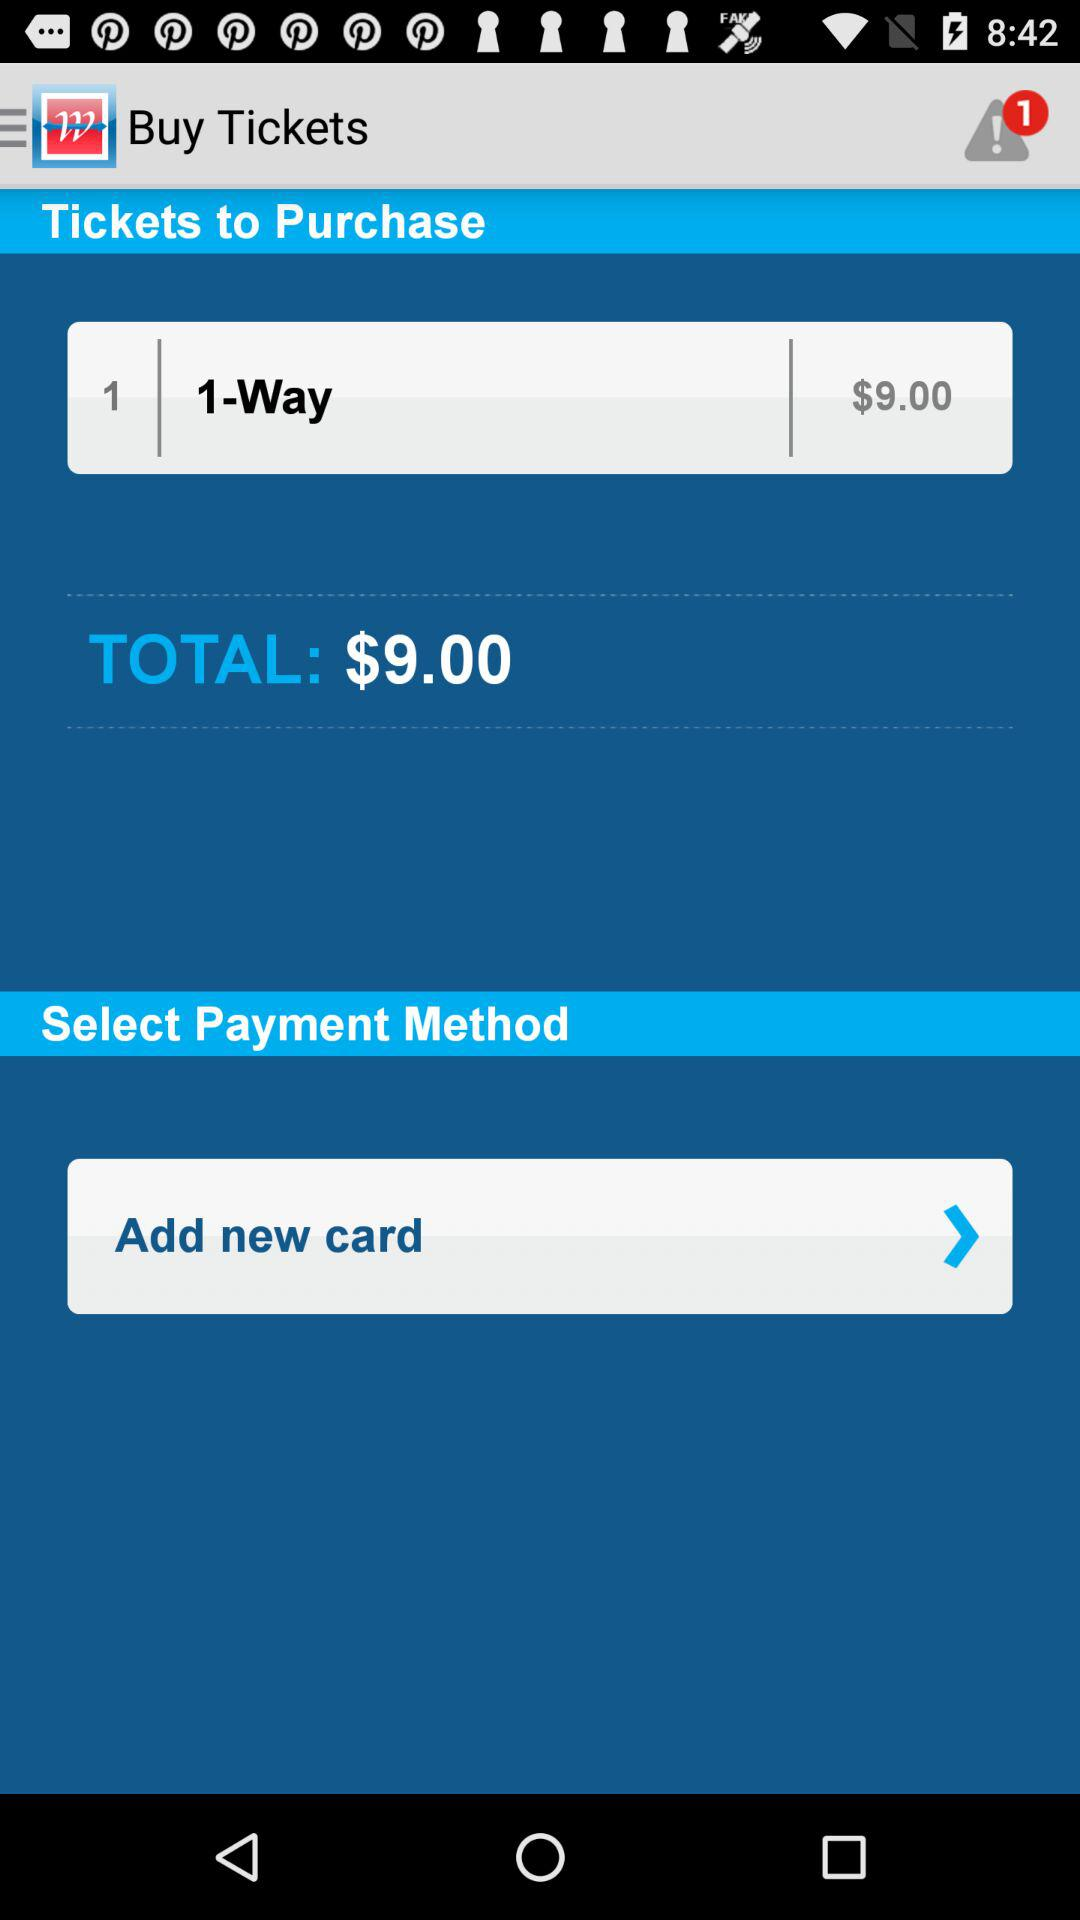How many tickets are being purchased?
Answer the question using a single word or phrase. 1 